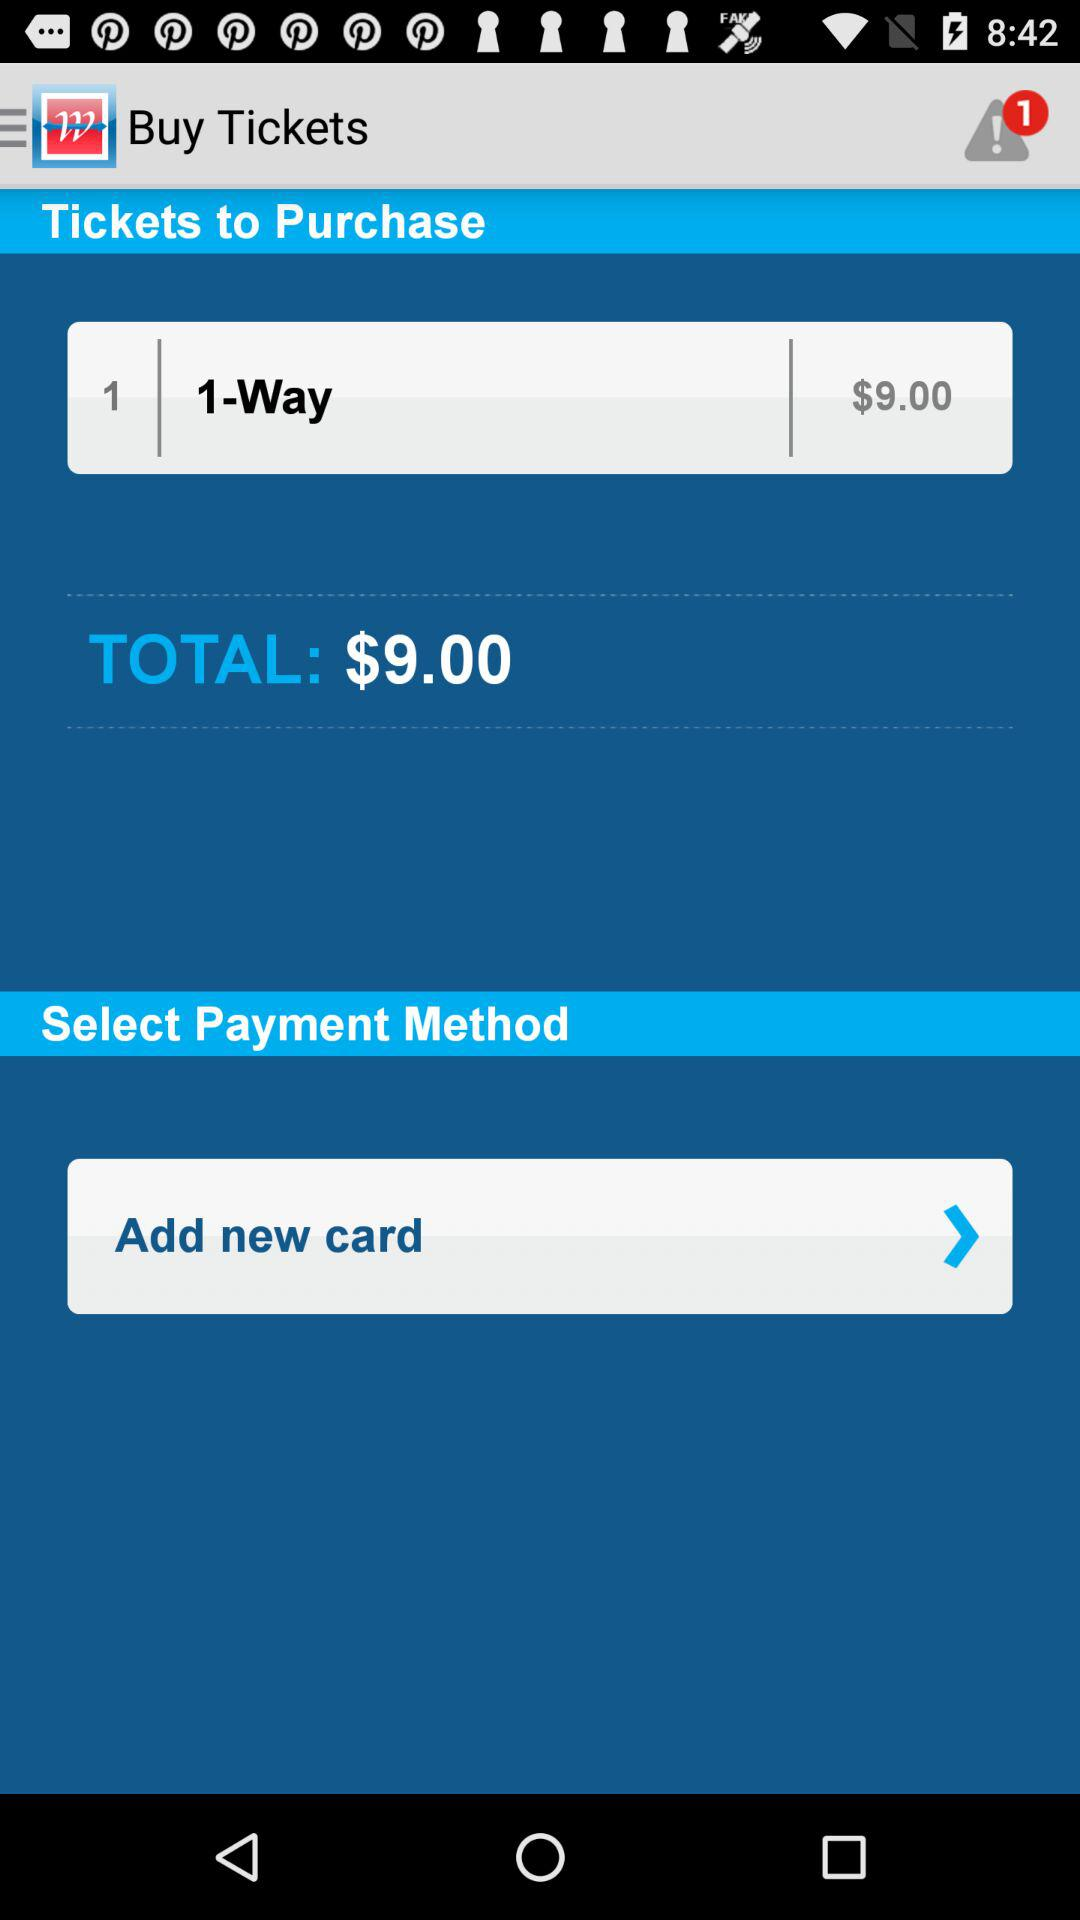How many tickets are being purchased?
Answer the question using a single word or phrase. 1 